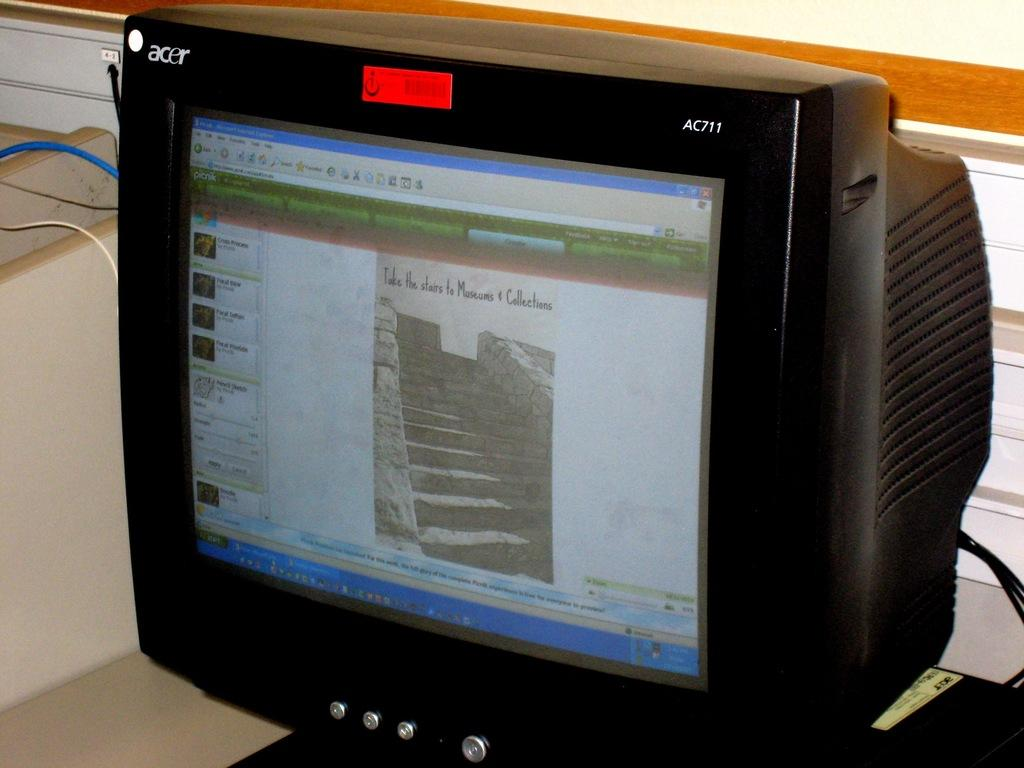Provide a one-sentence caption for the provided image. An Acer AC711 computer monitor shows a picture on the screen for Take the Stairs to Museums and Collections. 